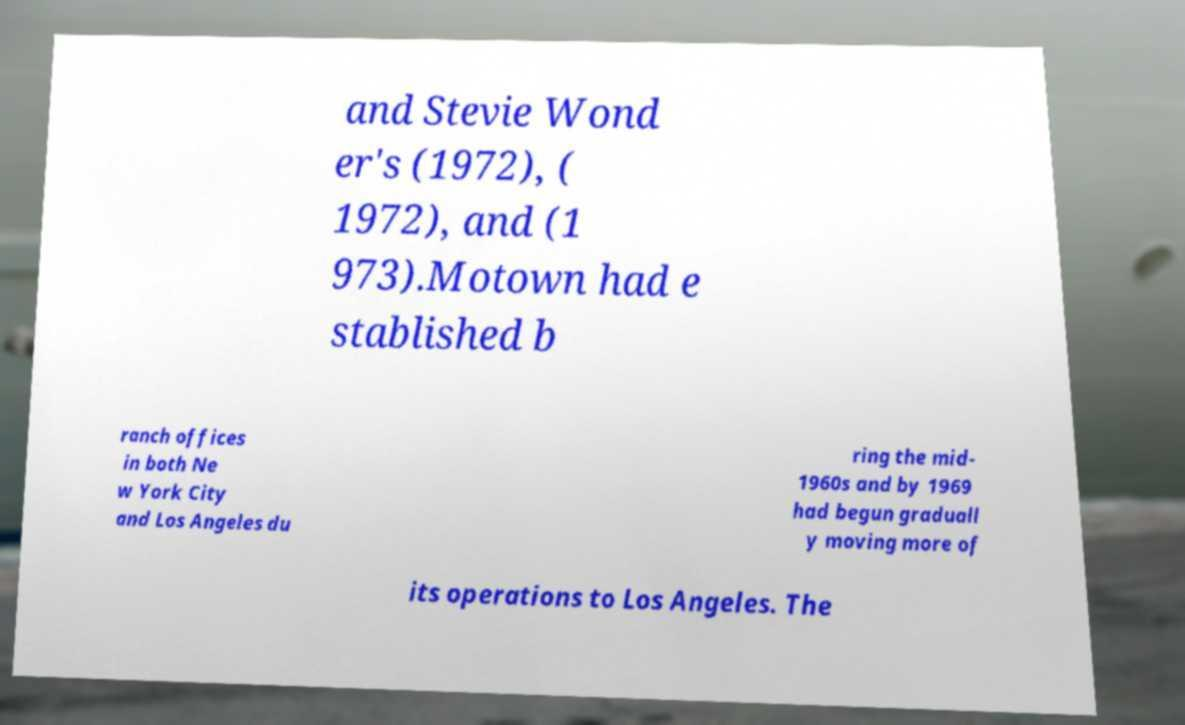Please read and relay the text visible in this image. What does it say? and Stevie Wond er's (1972), ( 1972), and (1 973).Motown had e stablished b ranch offices in both Ne w York City and Los Angeles du ring the mid- 1960s and by 1969 had begun graduall y moving more of its operations to Los Angeles. The 